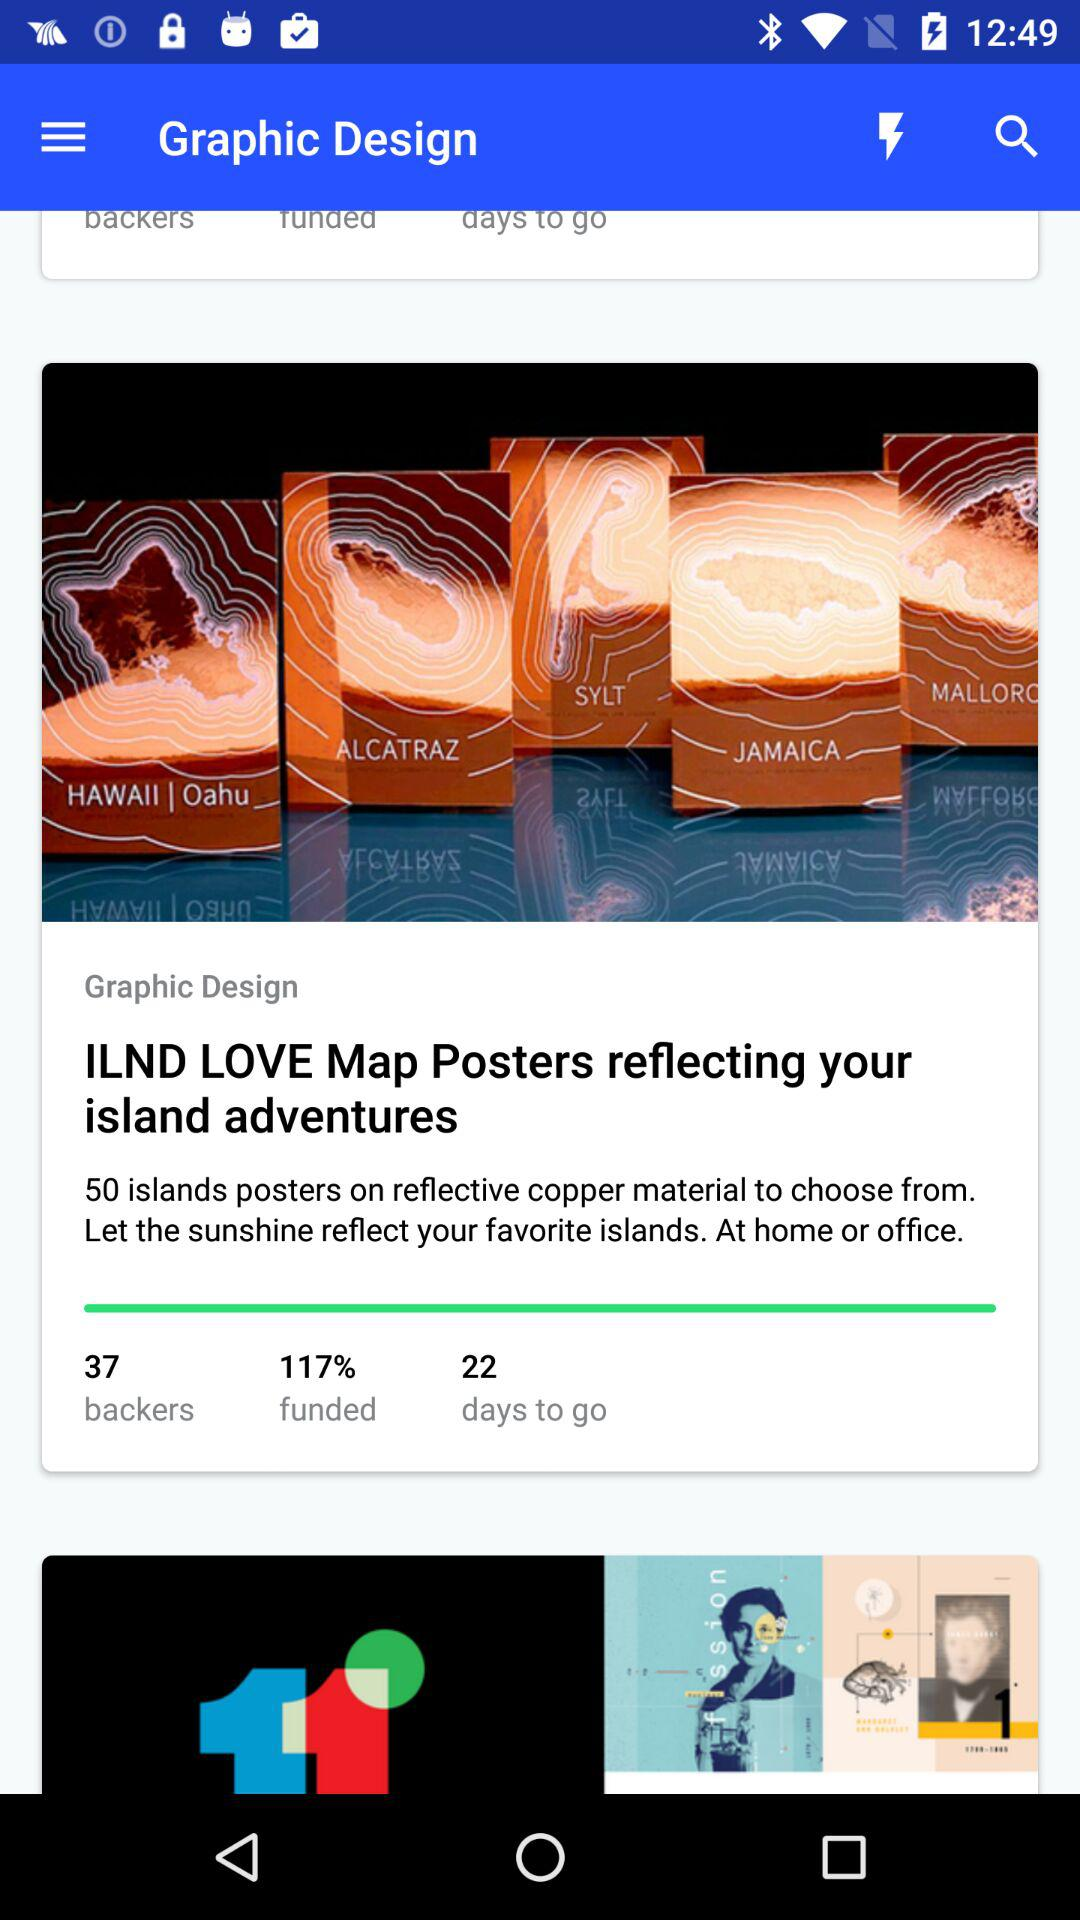What number of islands do the posters reflect? The posters reflect 50 islands. 